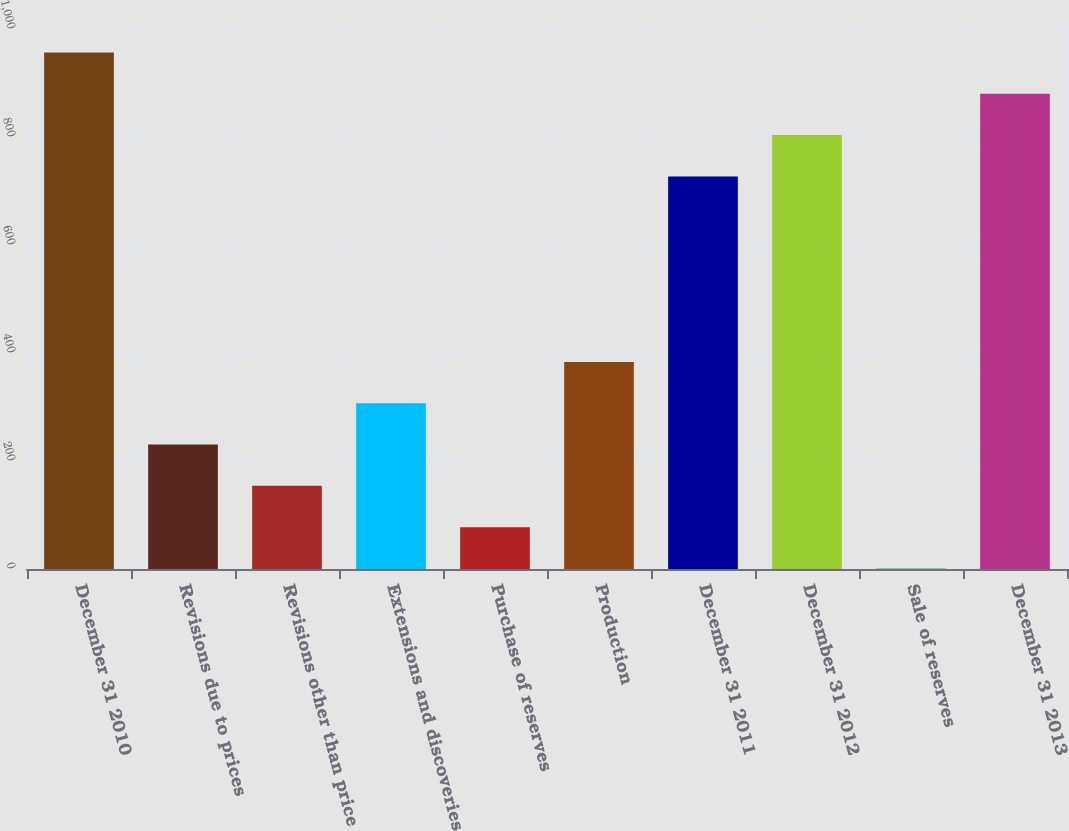<chart> <loc_0><loc_0><loc_500><loc_500><bar_chart><fcel>December 31 2010<fcel>Revisions due to prices<fcel>Revisions other than price<fcel>Extensions and discoveries<fcel>Purchase of reserves<fcel>Production<fcel>December 31 2011<fcel>December 31 2012<fcel>Sale of reserves<fcel>December 31 2013<nl><fcel>956.5<fcel>230.5<fcel>154<fcel>307<fcel>77.5<fcel>383.5<fcel>727<fcel>803.5<fcel>1<fcel>880<nl></chart> 